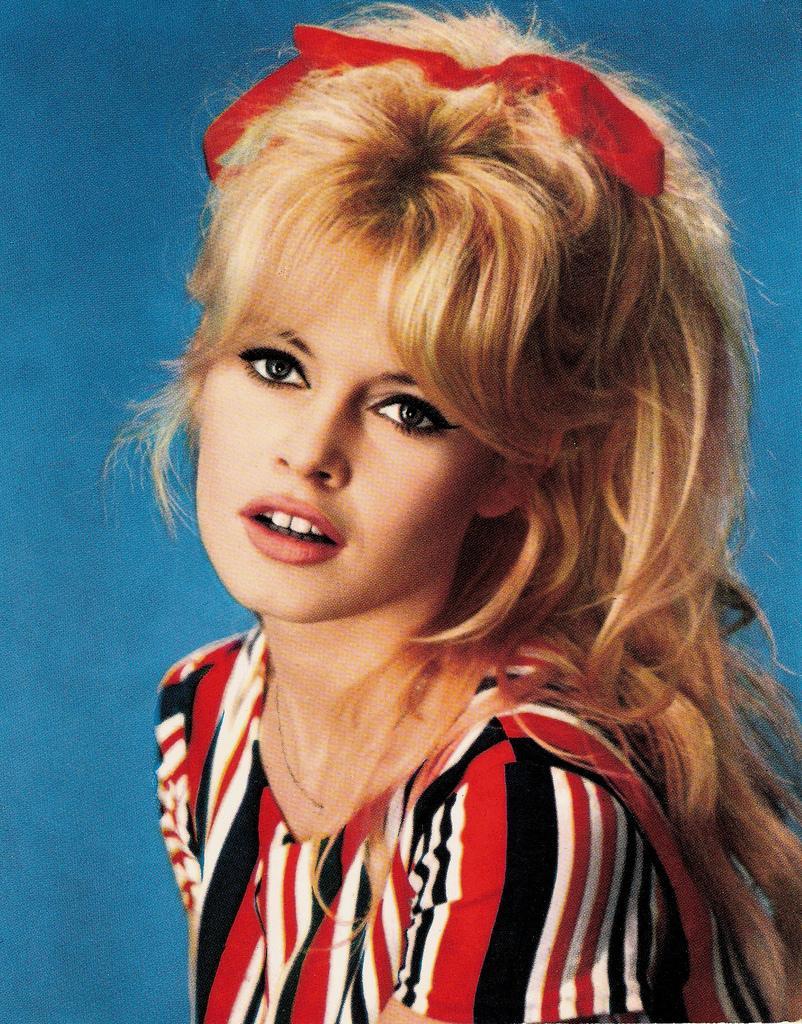In one or two sentences, can you explain what this image depicts? In this picture I can see there is a woman and she is wearing red color shirt and in the background there is a blue surface. 